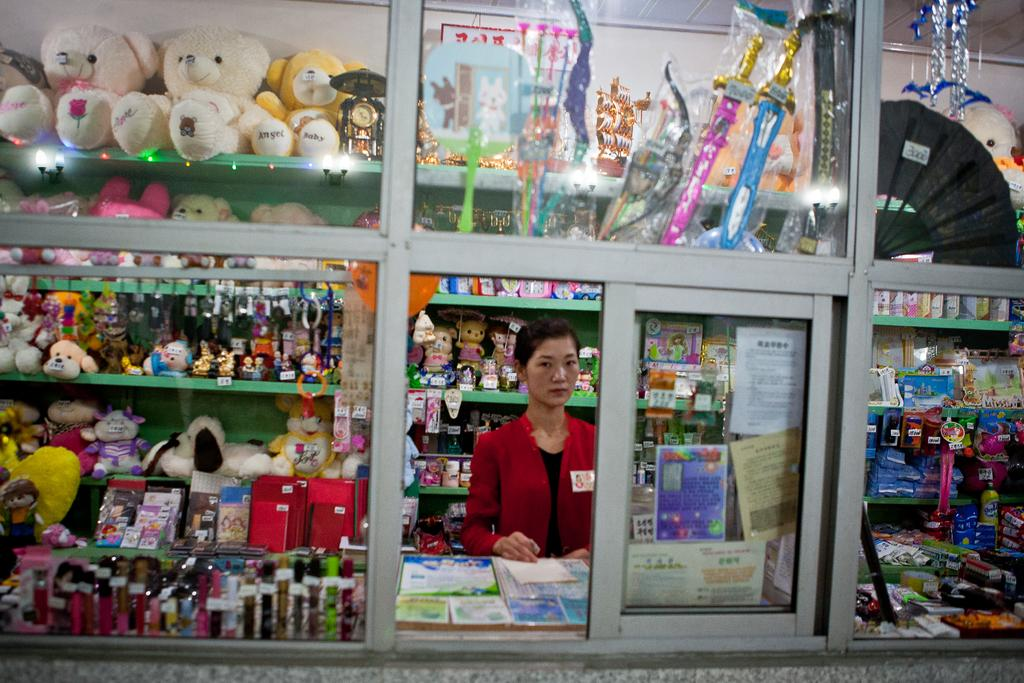What type of stall is shown in the image? The image depicts a toys stall. Can you describe the person at the stall? There is a person standing at the stall. What can be found at the toys stall? There are toys present in the stall. Are there any other items inside the stall besides toys? Yes, there are additional items inside the stall. What page of the book is the person reading at the toys stall? There is no book present in the image, and therefore no page to reference. 